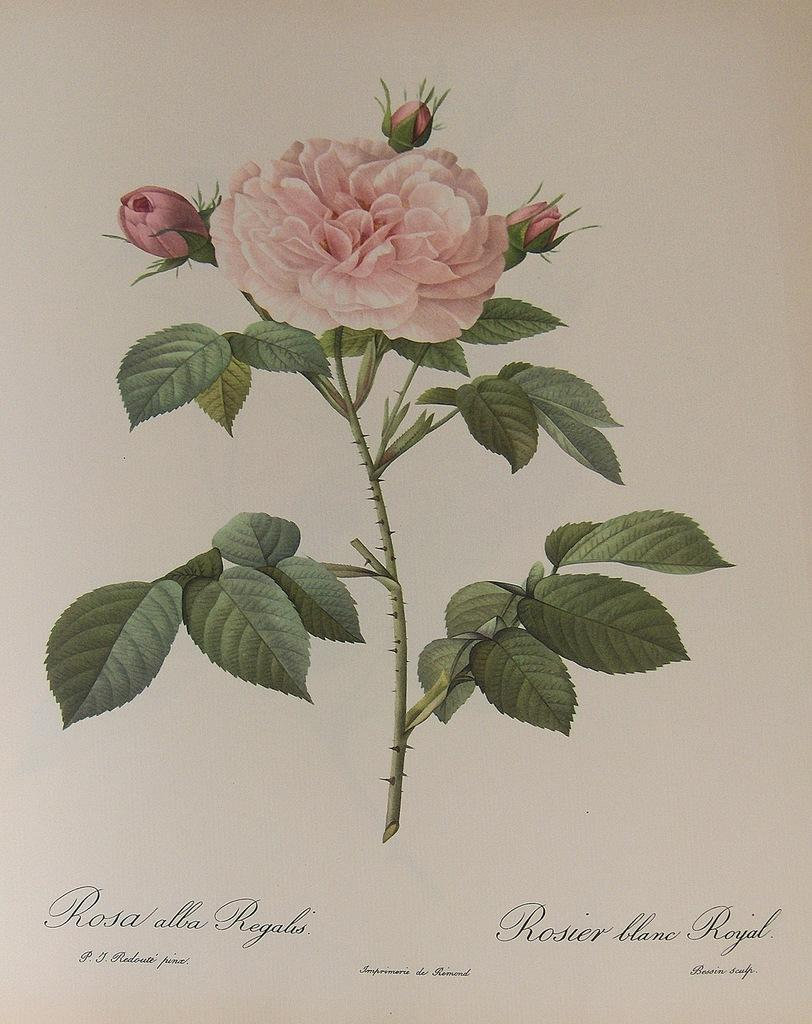What is the main subject of the image? The main subject of the image is a stem with thorns. What features can be observed on the stem? There are leaves, a pink flower, and buds on the stem. Is there any text present in the image? Yes, there is text written at the bottom of the image. What type of bridge can be seen in the image? There is no bridge present in the image. What time of day is it in the image, considering the afternoon? The time of day is not mentioned or depicted in the image, so it cannot be determined based on the afternoon. 